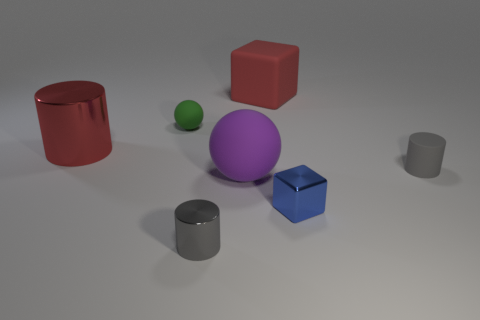Subtract all gray metallic cylinders. How many cylinders are left? 2 Add 1 tiny green metal balls. How many objects exist? 8 Subtract all red cylinders. How many cylinders are left? 2 Subtract 1 balls. How many balls are left? 1 Subtract 1 red cubes. How many objects are left? 6 Subtract all blocks. How many objects are left? 5 Subtract all yellow cylinders. Subtract all blue blocks. How many cylinders are left? 3 Subtract all purple cylinders. How many red cubes are left? 1 Subtract all green balls. Subtract all spheres. How many objects are left? 4 Add 2 large matte blocks. How many large matte blocks are left? 3 